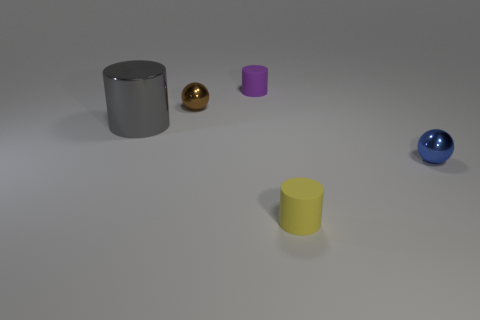Add 5 yellow rubber cylinders. How many objects exist? 10 Subtract all balls. How many objects are left? 3 Subtract 0 purple balls. How many objects are left? 5 Subtract all small blue metallic spheres. Subtract all small yellow rubber objects. How many objects are left? 3 Add 3 small yellow rubber things. How many small yellow rubber things are left? 4 Add 3 yellow things. How many yellow things exist? 4 